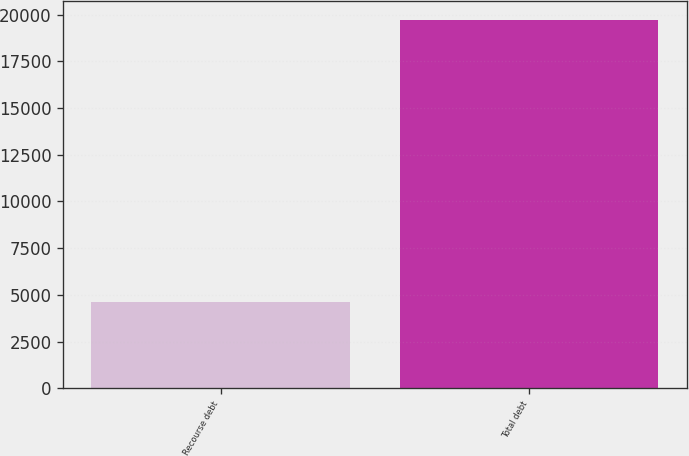Convert chart. <chart><loc_0><loc_0><loc_500><loc_500><bar_chart><fcel>Recourse debt<fcel>Total debt<nl><fcel>4612<fcel>19733<nl></chart> 